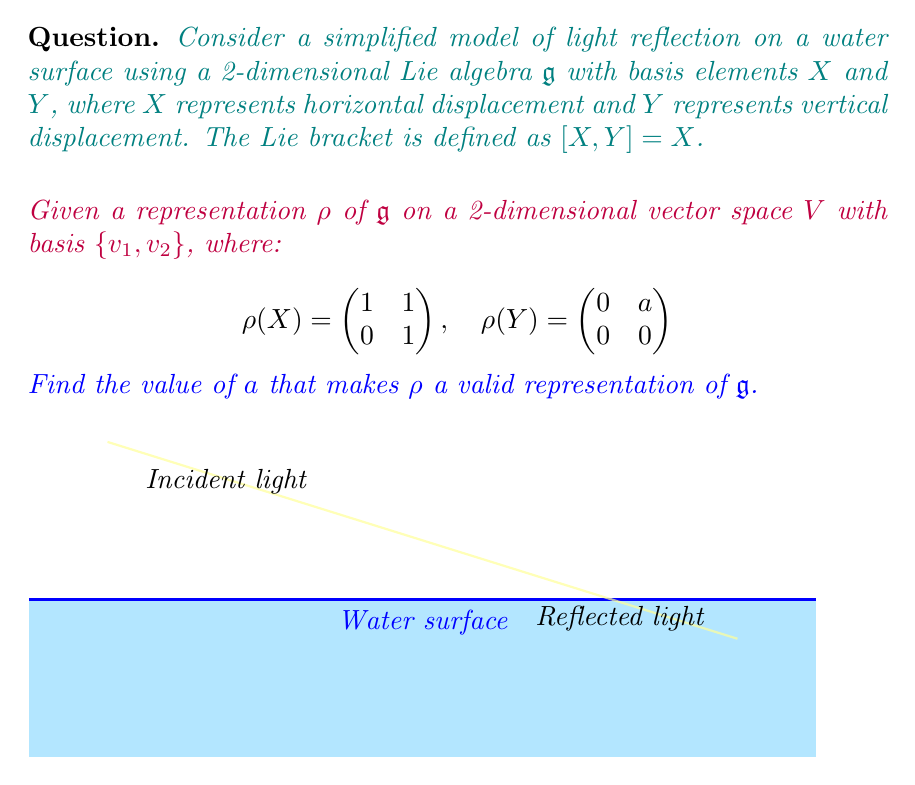Give your solution to this math problem. To solve this problem, we need to check if the given representation satisfies the Lie algebra relations. For a representation to be valid, it must preserve the Lie bracket. In this case, we need to verify:

$$\rho([X,Y]) = [\rho(X), \rho(Y)]$$

Step 1: Calculate the left-hand side
We know that $[X,Y] = X$, so:
$$\rho([X,Y]) = \rho(X) = \begin{pmatrix} 1 & 1 \\ 0 & 1 \end{pmatrix}$$

Step 2: Calculate the right-hand side
The commutator $[\rho(X), \rho(Y)]$ is defined as $\rho(X)\rho(Y) - \rho(Y)\rho(X)$:

$$[\rho(X), \rho(Y)] = \begin{pmatrix} 1 & 1 \\ 0 & 1 \end{pmatrix} \begin{pmatrix} 0 & a \\ 0 & 0 \end{pmatrix} - \begin{pmatrix} 0 & a \\ 0 & 0 \end{pmatrix} \begin{pmatrix} 1 & 1 \\ 0 & 1 \end{pmatrix}$$

$$= \begin{pmatrix} 0 & a \\ 0 & 0 \end{pmatrix} - \begin{pmatrix} 0 & a \\ 0 & 0 \end{pmatrix} = \begin{pmatrix} 0 & 0 \\ 0 & 0 \end{pmatrix}$$

Step 3: Equate both sides
For $\rho$ to be a valid representation, we must have:

$$\begin{pmatrix} 1 & 1 \\ 0 & 1 \end{pmatrix} = \begin{pmatrix} 0 & 0 \\ 0 & 0 \end{pmatrix}$$

Step 4: Conclusion
We can see that the equation above is not satisfied for any value of $a$. This means that the given representation $\rho$ is not a valid representation of the Lie algebra $\mathfrak{g}$ for any value of $a$.
Answer: No value of $a$ makes $\rho$ a valid representation. 